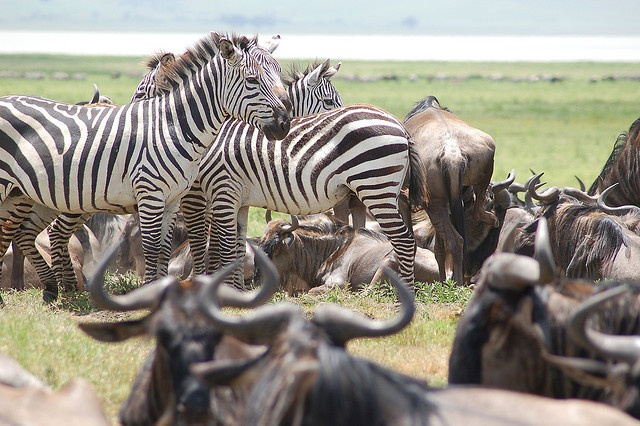Describe the objects in this image and their specific colors. I can see zebra in lightgray, darkgray, black, and gray tones, zebra in lightgray, darkgray, black, and gray tones, zebra in lightgray, black, gray, and white tones, zebra in lightgray, darkgray, gray, and black tones, and zebra in lightgray, black, gray, and tan tones in this image. 